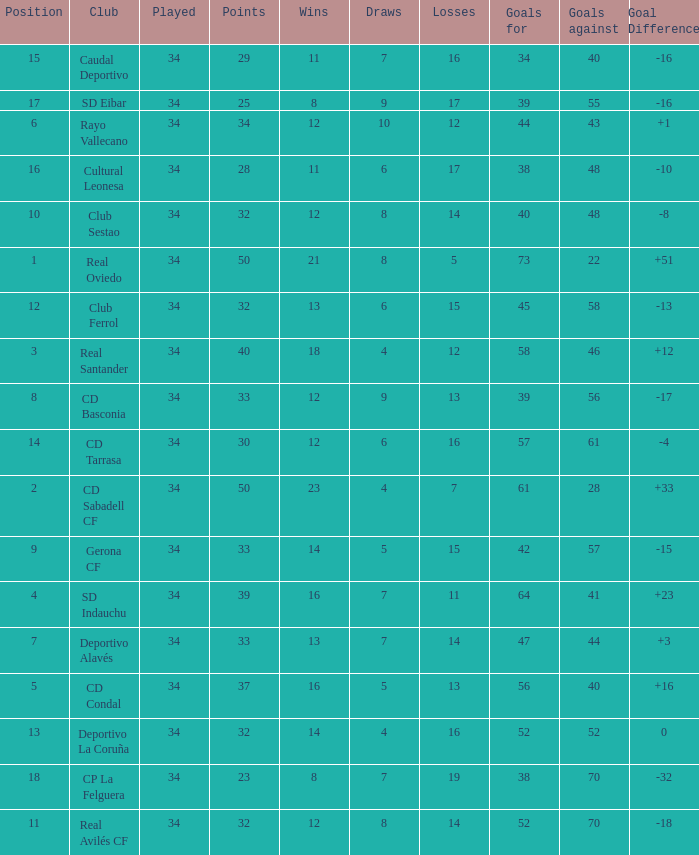How many Goals against have Played more than 34? 0.0. Give me the full table as a dictionary. {'header': ['Position', 'Club', 'Played', 'Points', 'Wins', 'Draws', 'Losses', 'Goals for', 'Goals against', 'Goal Difference'], 'rows': [['15', 'Caudal Deportivo', '34', '29', '11', '7', '16', '34', '40', '-16'], ['17', 'SD Eibar', '34', '25', '8', '9', '17', '39', '55', '-16'], ['6', 'Rayo Vallecano', '34', '34', '12', '10', '12', '44', '43', '+1'], ['16', 'Cultural Leonesa', '34', '28', '11', '6', '17', '38', '48', '-10'], ['10', 'Club Sestao', '34', '32', '12', '8', '14', '40', '48', '-8'], ['1', 'Real Oviedo', '34', '50', '21', '8', '5', '73', '22', '+51'], ['12', 'Club Ferrol', '34', '32', '13', '6', '15', '45', '58', '-13'], ['3', 'Real Santander', '34', '40', '18', '4', '12', '58', '46', '+12'], ['8', 'CD Basconia', '34', '33', '12', '9', '13', '39', '56', '-17'], ['14', 'CD Tarrasa', '34', '30', '12', '6', '16', '57', '61', '-4'], ['2', 'CD Sabadell CF', '34', '50', '23', '4', '7', '61', '28', '+33'], ['9', 'Gerona CF', '34', '33', '14', '5', '15', '42', '57', '-15'], ['4', 'SD Indauchu', '34', '39', '16', '7', '11', '64', '41', '+23'], ['7', 'Deportivo Alavés', '34', '33', '13', '7', '14', '47', '44', '+3'], ['5', 'CD Condal', '34', '37', '16', '5', '13', '56', '40', '+16'], ['13', 'Deportivo La Coruña', '34', '32', '14', '4', '16', '52', '52', '0'], ['18', 'CP La Felguera', '34', '23', '8', '7', '19', '38', '70', '-32'], ['11', 'Real Avilés CF', '34', '32', '12', '8', '14', '52', '70', '-18']]} 